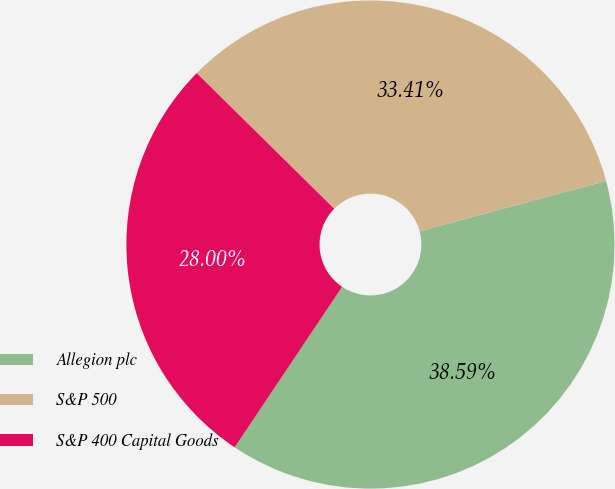<chart> <loc_0><loc_0><loc_500><loc_500><pie_chart><fcel>Allegion plc<fcel>S&P 500<fcel>S&P 400 Capital Goods<nl><fcel>38.59%<fcel>33.41%<fcel>28.0%<nl></chart> 